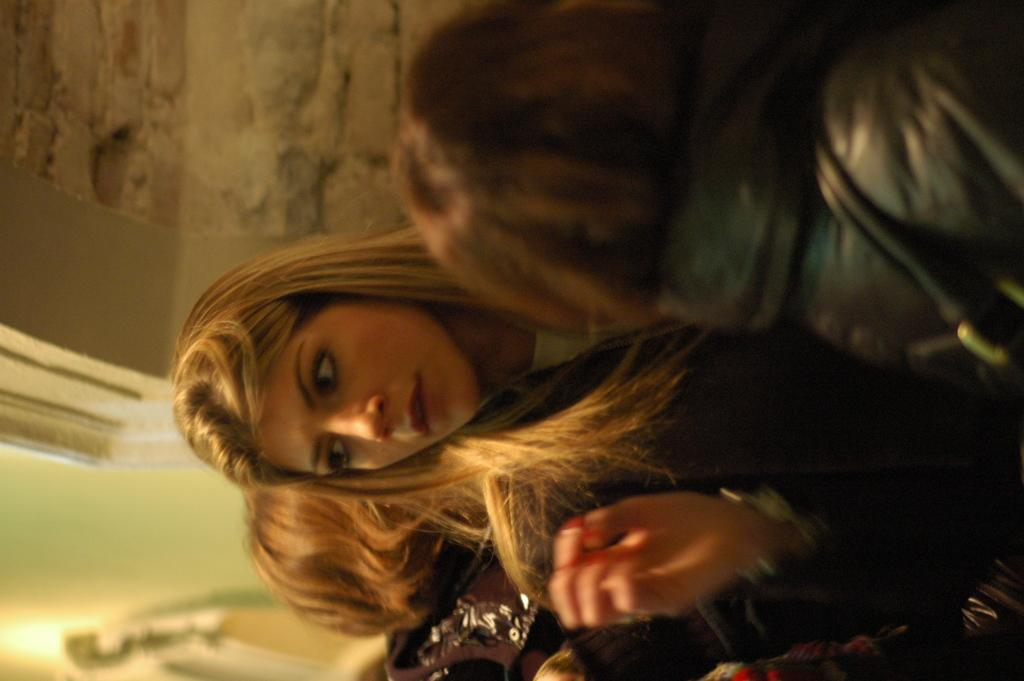Who or what can be seen in the image? There are people in the image. What is visible in the background of the image? There is a wall in the background of the image. What type of mitten is being worn by the people in the image? There is no mitten visible in the image; the people are not wearing any gloves or mittens. 